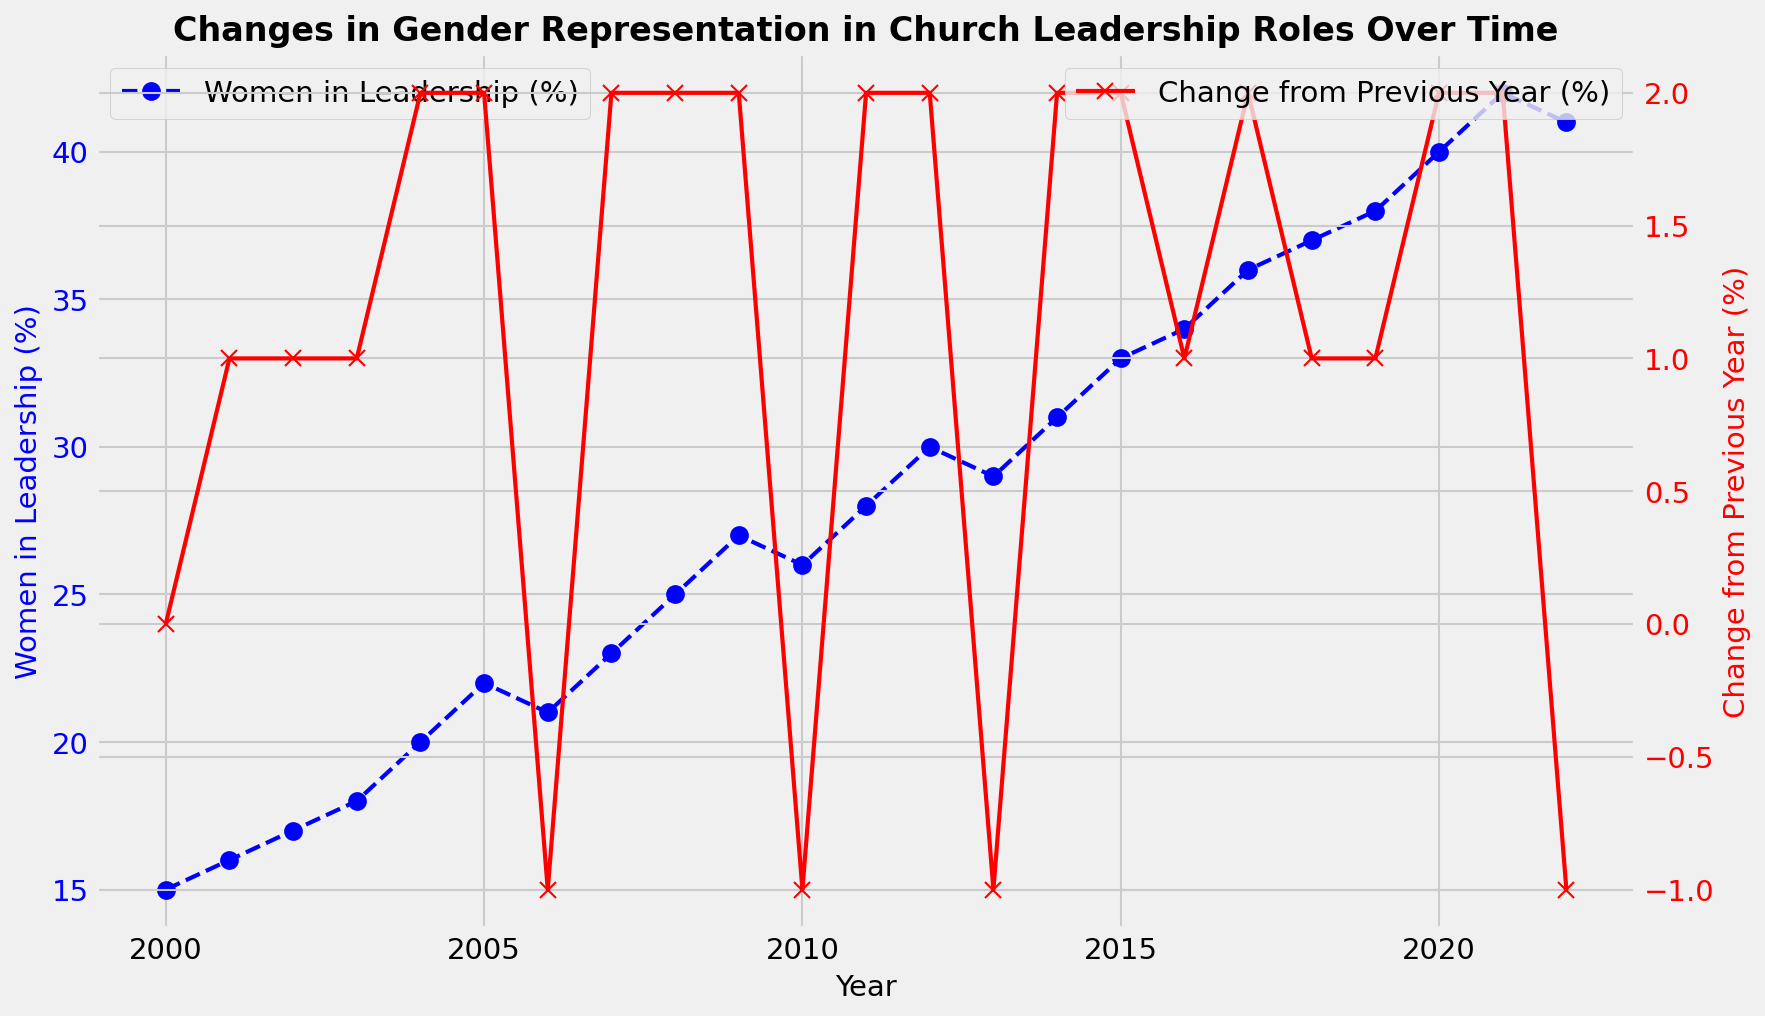What is the percentage of women in leadership in 2020? To find the percentage of women in leadership in 2020, we look at the value of the blue line corresponding to the year 2020.
Answer: 40% What year had the largest decrease in women in leadership? By observing the red line indicating the change from the previous year, we identify the largest negative value. The largest decrease is -1%, visible at the years 2006, 2010, 2013, and 2022.
Answer: 2006, 2010, 2013, 2022 How did the percentage of women in leadership change from 2016 to 2018? To find the change from 2016 to 2018, look at the blue line at 2016 (34%) and 2018 (37%), then compute the difference: 37 - 34.
Answer: Increased by 3% What is the average change from the previous year between 2010 and 2020? Calculate the average of the changes from 2010 to 2020, which are: -1, 2, 2, -1, 2, 2, 1, 2, 1, 1, and 2. Sum these values: -1 + 2 + 2 - 1 + 2 + 2 + 1 + 2 + 1 + 1 + 2 = 13. Divide by the number of years: 13/11.
Answer: 1.18% In what year did the percentage of women in leadership first exceed 30%? Look for the year when the blue line first crosses above the 30% mark. This occurs in 2012.
Answer: 2012 Compare the percentage of women in leadership in 2005 and 2020. Which year had a higher percentage? Find the percentage of women in leadership for both years from the blue line: 2005 (22%) and 2020 (40%). 2020 had a higher percentage.
Answer: 2020 What was the percentage change in women leadership from 2003 to 2004? Find the percentage of women in leadership for 2003 (18%) and 2004 (20%) from the blue line. Compute the difference: 20 - 18.
Answer: 2% Was the percentage of women in leadership ever the same in any two consecutive years? To check if the line for ‘Women in Leadership (%)’ remains constant over any consecutive years, observe the blue line. No part of the blue line is flat, indicating continuous changes year by year.
Answer: No What is the maximum percentage of women in leadership observed on the chart? Look at the highest point of the blue line across all years, which occurs in 2021 (42%).
Answer: 42% 